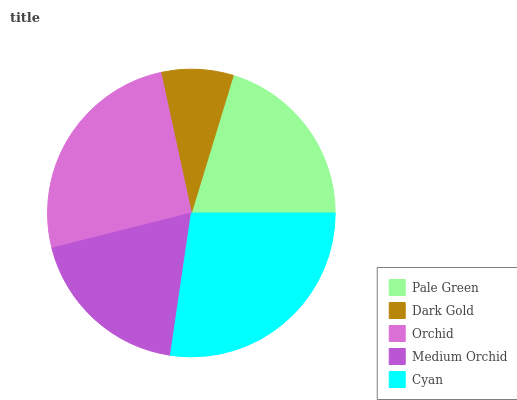Is Dark Gold the minimum?
Answer yes or no. Yes. Is Cyan the maximum?
Answer yes or no. Yes. Is Orchid the minimum?
Answer yes or no. No. Is Orchid the maximum?
Answer yes or no. No. Is Orchid greater than Dark Gold?
Answer yes or no. Yes. Is Dark Gold less than Orchid?
Answer yes or no. Yes. Is Dark Gold greater than Orchid?
Answer yes or no. No. Is Orchid less than Dark Gold?
Answer yes or no. No. Is Pale Green the high median?
Answer yes or no. Yes. Is Pale Green the low median?
Answer yes or no. Yes. Is Cyan the high median?
Answer yes or no. No. Is Medium Orchid the low median?
Answer yes or no. No. 